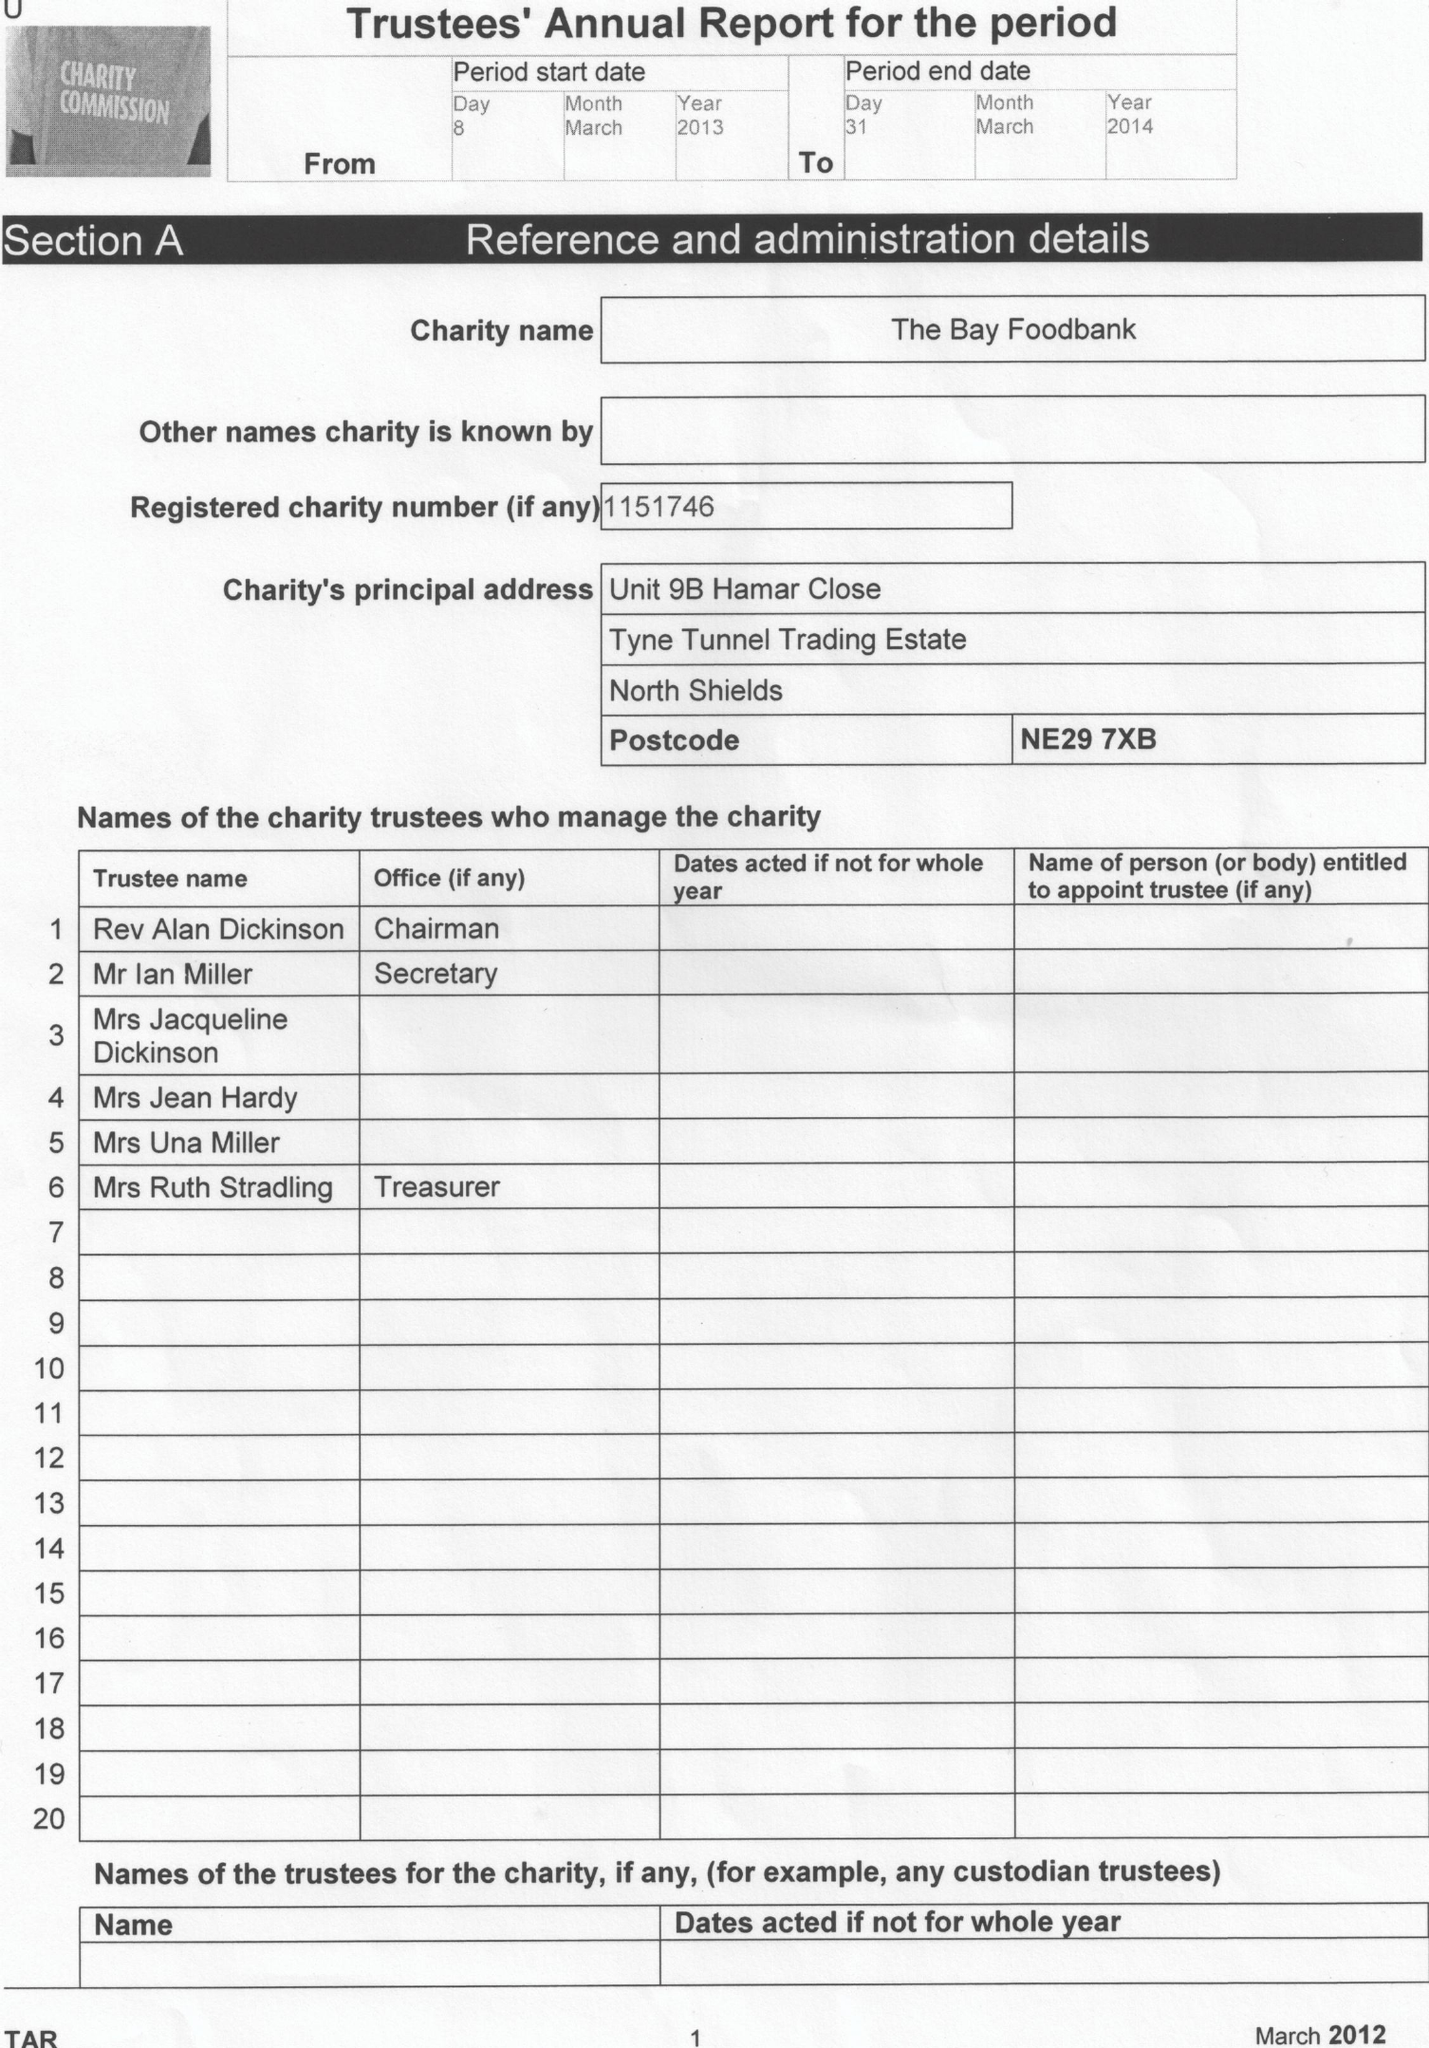What is the value for the spending_annually_in_british_pounds?
Answer the question using a single word or phrase. 22670.00 